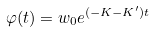Convert formula to latex. <formula><loc_0><loc_0><loc_500><loc_500>\varphi ( t ) = w _ { 0 } e ^ { ( - K - K ^ { \prime } ) t }</formula> 